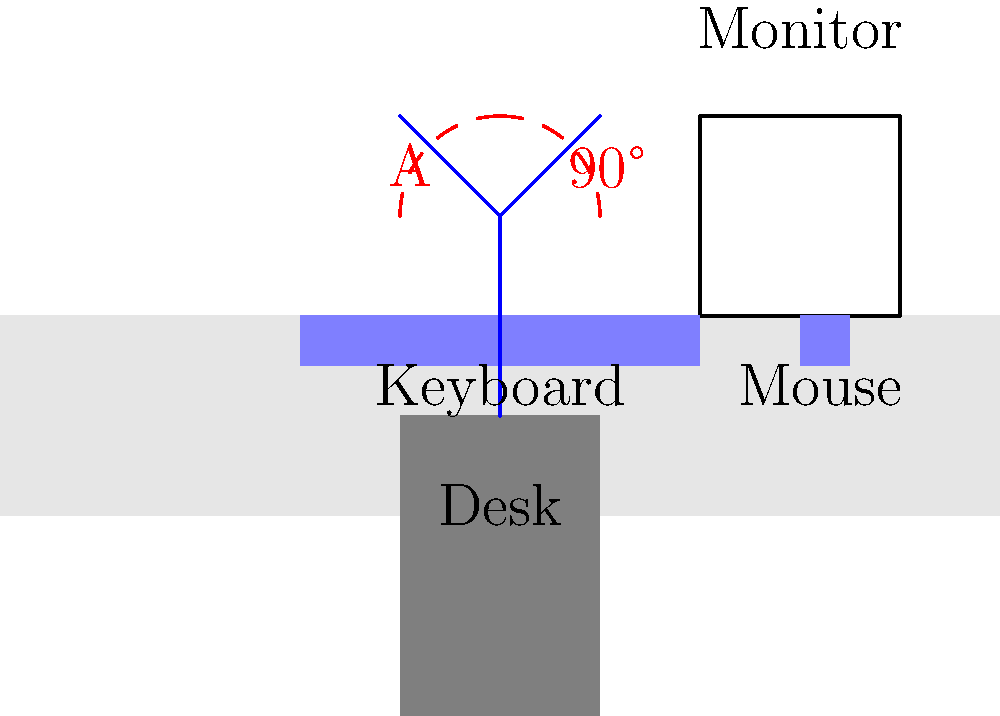In the ergonomic workspace design shown above, what should the angle labeled 'A' ideally be to minimize the risk of repetitive strain injuries in the upper arms and shoulders? To determine the ideal angle for minimizing repetitive strain injuries in the upper arms and shoulders, we need to consider the following steps:

1. Ergonomic principles suggest that the upper arms should be relaxed and close to the body when working at a desk.

2. The ideal posture for the upper arms is to have them hanging naturally from the shoulders, with minimal tension.

3. This natural, relaxed position typically forms a 90-degree angle between the upper arm and the forearm when the hands are placed on the keyboard or mouse.

4. In the diagram, we can see that there's a 90-degree angle marked between the vertical line (representing the upper arm) and the horizontal line.

5. The angle labeled 'A' is the complementary angle to this 90-degree angle.

6. In geometry, complementary angles add up to 90 degrees. Therefore, if one angle is 90 degrees, its complement (angle A) must be:

   $$90^\circ - 90^\circ = 0^\circ$$

7. A 0-degree angle for 'A' means that the upper arm is perfectly vertical, which is the ideal position for minimizing strain on the shoulders and upper arms.

This vertical alignment of the upper arms allows for a neutral shoulder position, reducing the risk of developing conditions like shoulder impingement or rotator cuff injuries over time.
Answer: 0 degrees 